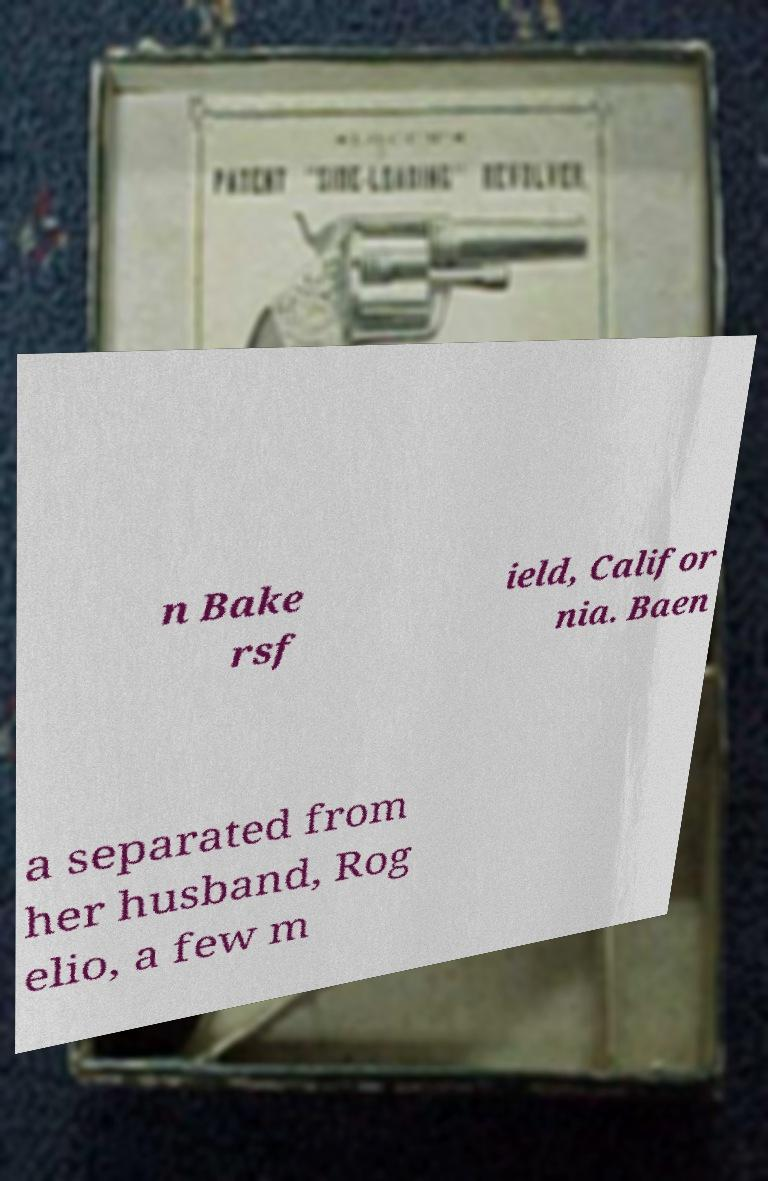Please read and relay the text visible in this image. What does it say? n Bake rsf ield, Califor nia. Baen a separated from her husband, Rog elio, a few m 